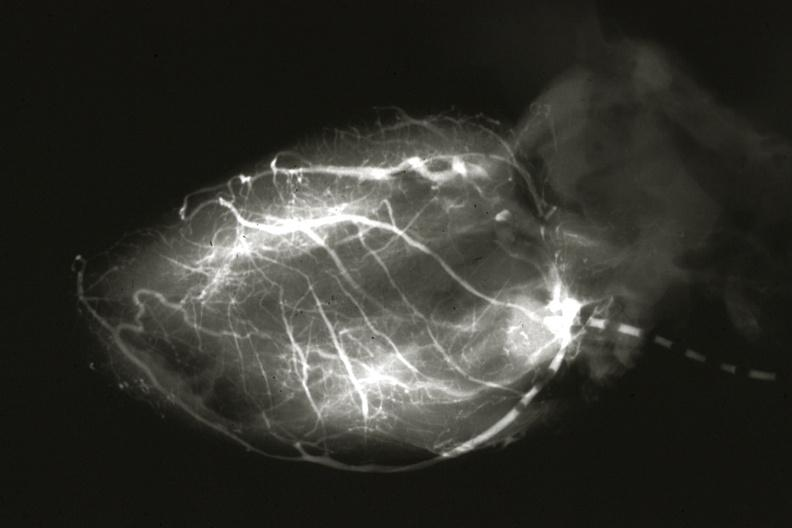what left from pulmonary artery?
Answer the question using a single word or phrase. Anomalous origin 